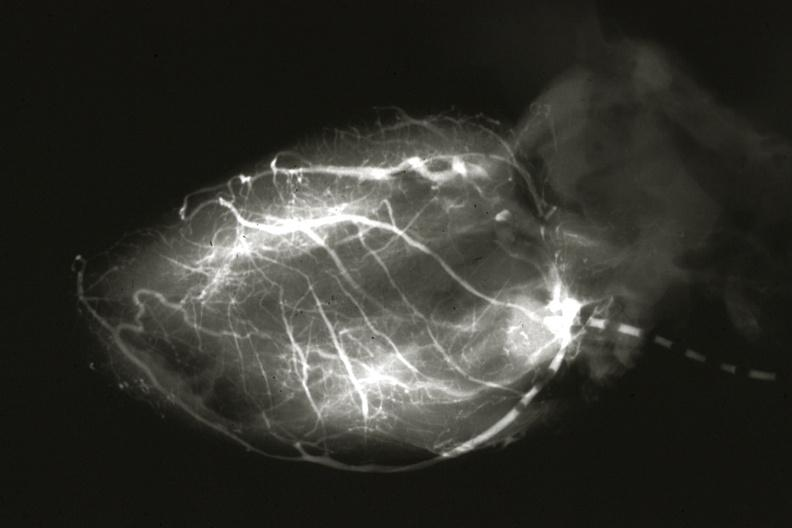what left from pulmonary artery?
Answer the question using a single word or phrase. Anomalous origin 